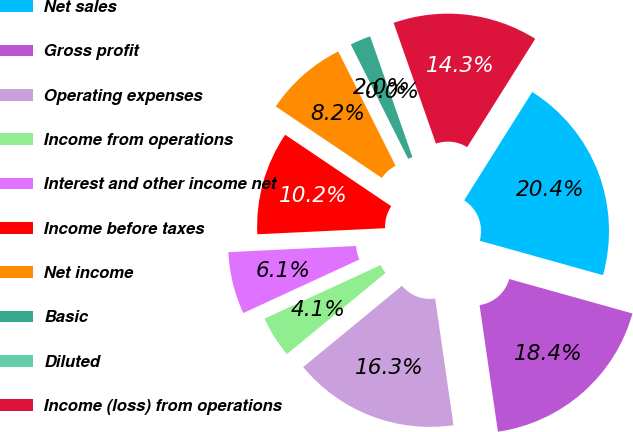Convert chart. <chart><loc_0><loc_0><loc_500><loc_500><pie_chart><fcel>Net sales<fcel>Gross profit<fcel>Operating expenses<fcel>Income from operations<fcel>Interest and other income net<fcel>Income before taxes<fcel>Net income<fcel>Basic<fcel>Diluted<fcel>Income (loss) from operations<nl><fcel>20.41%<fcel>18.37%<fcel>16.33%<fcel>4.08%<fcel>6.12%<fcel>10.2%<fcel>8.16%<fcel>2.04%<fcel>0.0%<fcel>14.29%<nl></chart> 